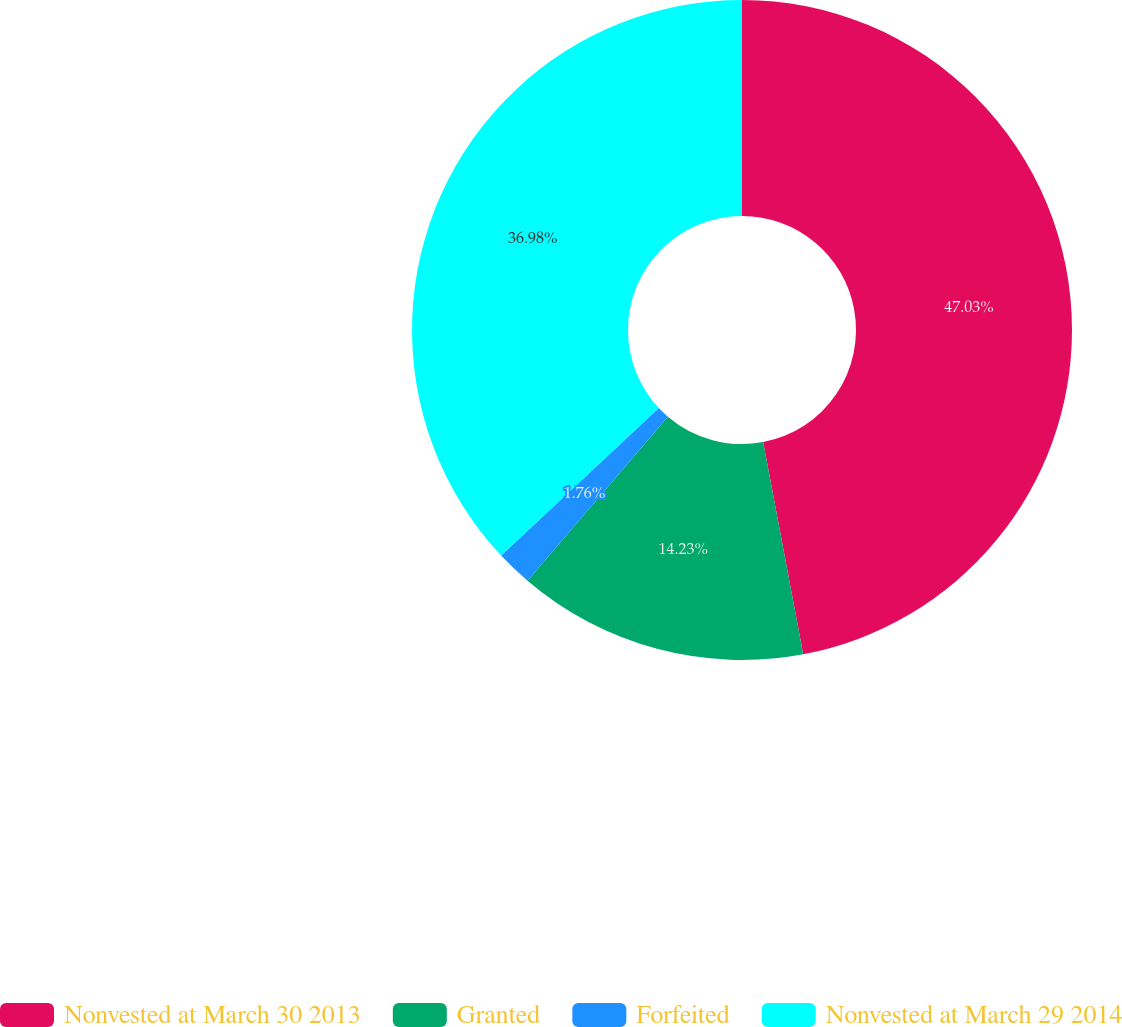<chart> <loc_0><loc_0><loc_500><loc_500><pie_chart><fcel>Nonvested at March 30 2013<fcel>Granted<fcel>Forfeited<fcel>Nonvested at March 29 2014<nl><fcel>47.03%<fcel>14.23%<fcel>1.76%<fcel>36.98%<nl></chart> 